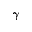Convert formula to latex. <formula><loc_0><loc_0><loc_500><loc_500>\gamma</formula> 